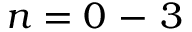<formula> <loc_0><loc_0><loc_500><loc_500>n = 0 - 3</formula> 